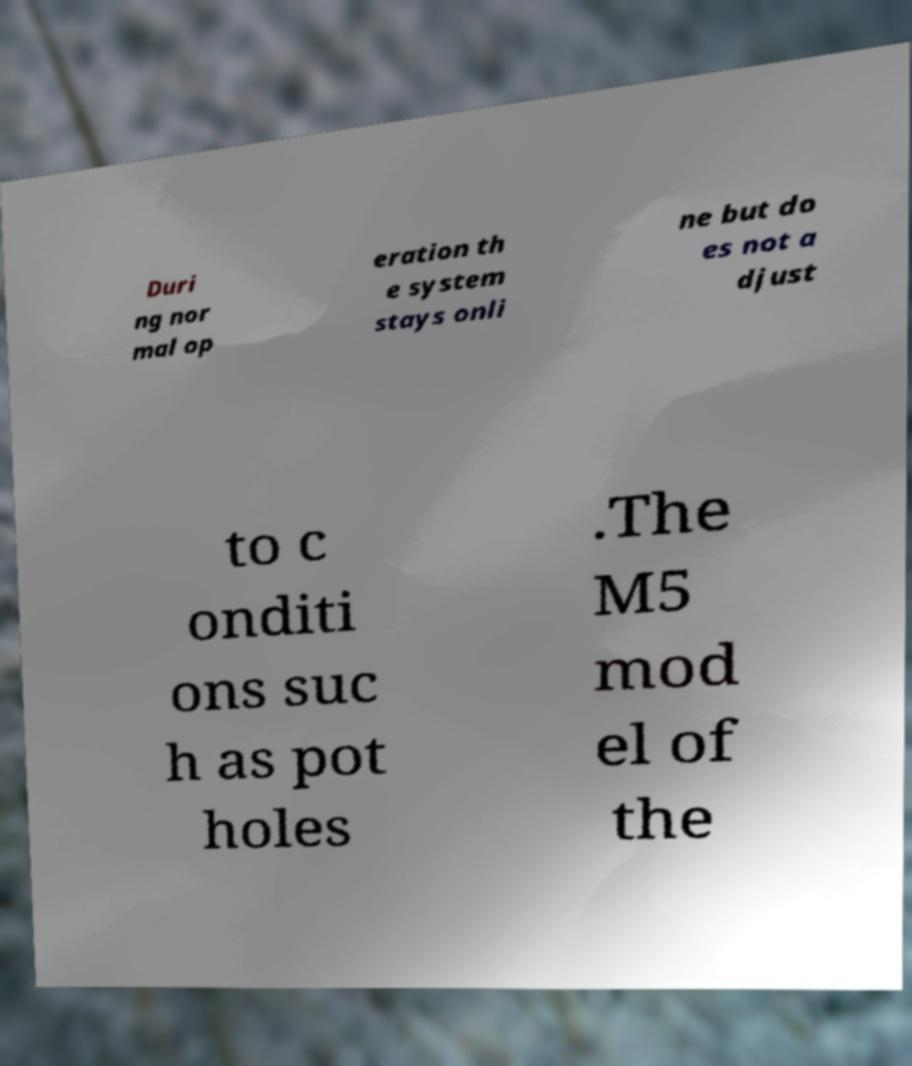What messages or text are displayed in this image? I need them in a readable, typed format. Duri ng nor mal op eration th e system stays onli ne but do es not a djust to c onditi ons suc h as pot holes .The M5 mod el of the 